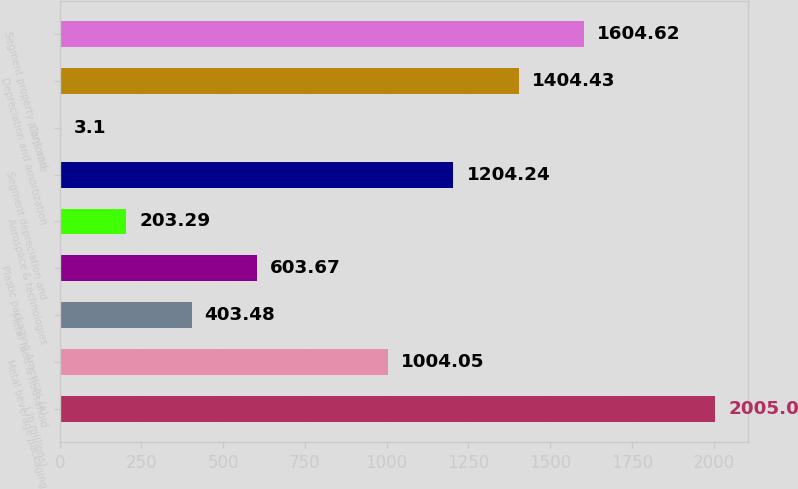Convert chart to OTSL. <chart><loc_0><loc_0><loc_500><loc_500><bar_chart><fcel>( in millions)<fcel>Metal beverage packaging<fcel>Metal food & household<fcel>Plastic packaging Americas (a)<fcel>Aerospace & technologies<fcel>Segment depreciation and<fcel>Corporate<fcel>Depreciation and amortization<fcel>Segment property plant and<nl><fcel>2005<fcel>1004.05<fcel>403.48<fcel>603.67<fcel>203.29<fcel>1204.24<fcel>3.1<fcel>1404.43<fcel>1604.62<nl></chart> 